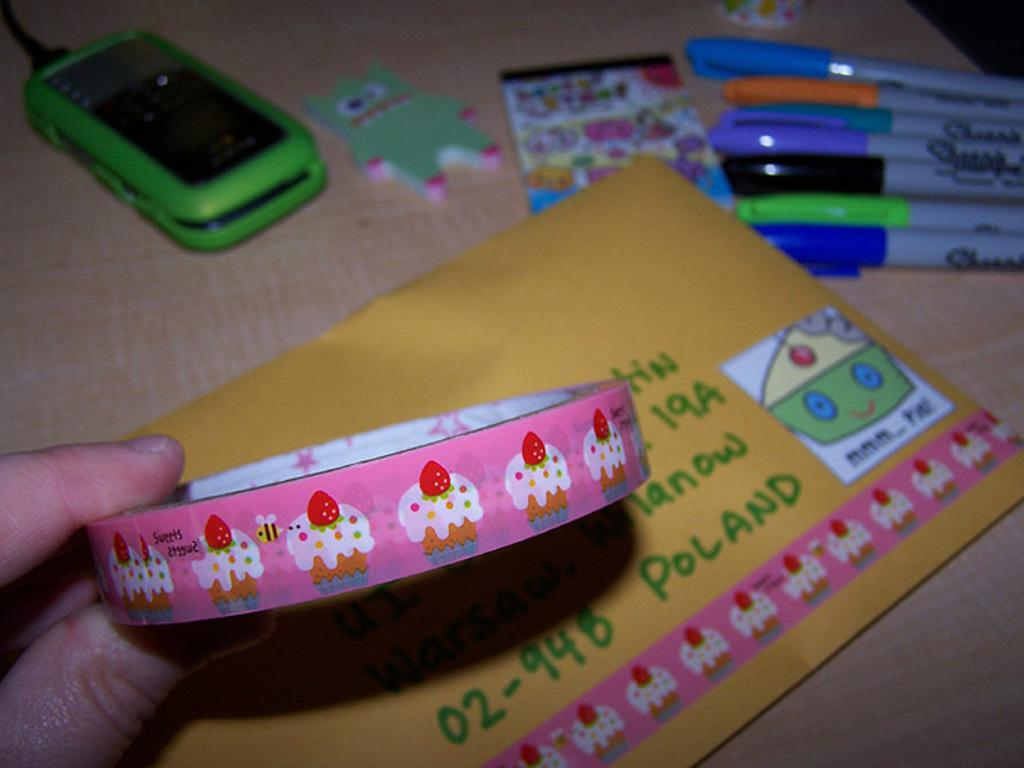<image>
Render a clear and concise summary of the photo. An yellow envelope is addressed to a Poland. 